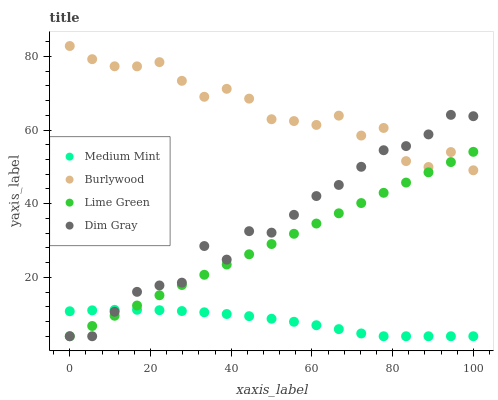Does Medium Mint have the minimum area under the curve?
Answer yes or no. Yes. Does Burlywood have the maximum area under the curve?
Answer yes or no. Yes. Does Dim Gray have the minimum area under the curve?
Answer yes or no. No. Does Dim Gray have the maximum area under the curve?
Answer yes or no. No. Is Lime Green the smoothest?
Answer yes or no. Yes. Is Burlywood the roughest?
Answer yes or no. Yes. Is Dim Gray the smoothest?
Answer yes or no. No. Is Dim Gray the roughest?
Answer yes or no. No. Does Medium Mint have the lowest value?
Answer yes or no. Yes. Does Burlywood have the lowest value?
Answer yes or no. No. Does Burlywood have the highest value?
Answer yes or no. Yes. Does Dim Gray have the highest value?
Answer yes or no. No. Is Medium Mint less than Burlywood?
Answer yes or no. Yes. Is Burlywood greater than Medium Mint?
Answer yes or no. Yes. Does Medium Mint intersect Lime Green?
Answer yes or no. Yes. Is Medium Mint less than Lime Green?
Answer yes or no. No. Is Medium Mint greater than Lime Green?
Answer yes or no. No. Does Medium Mint intersect Burlywood?
Answer yes or no. No. 